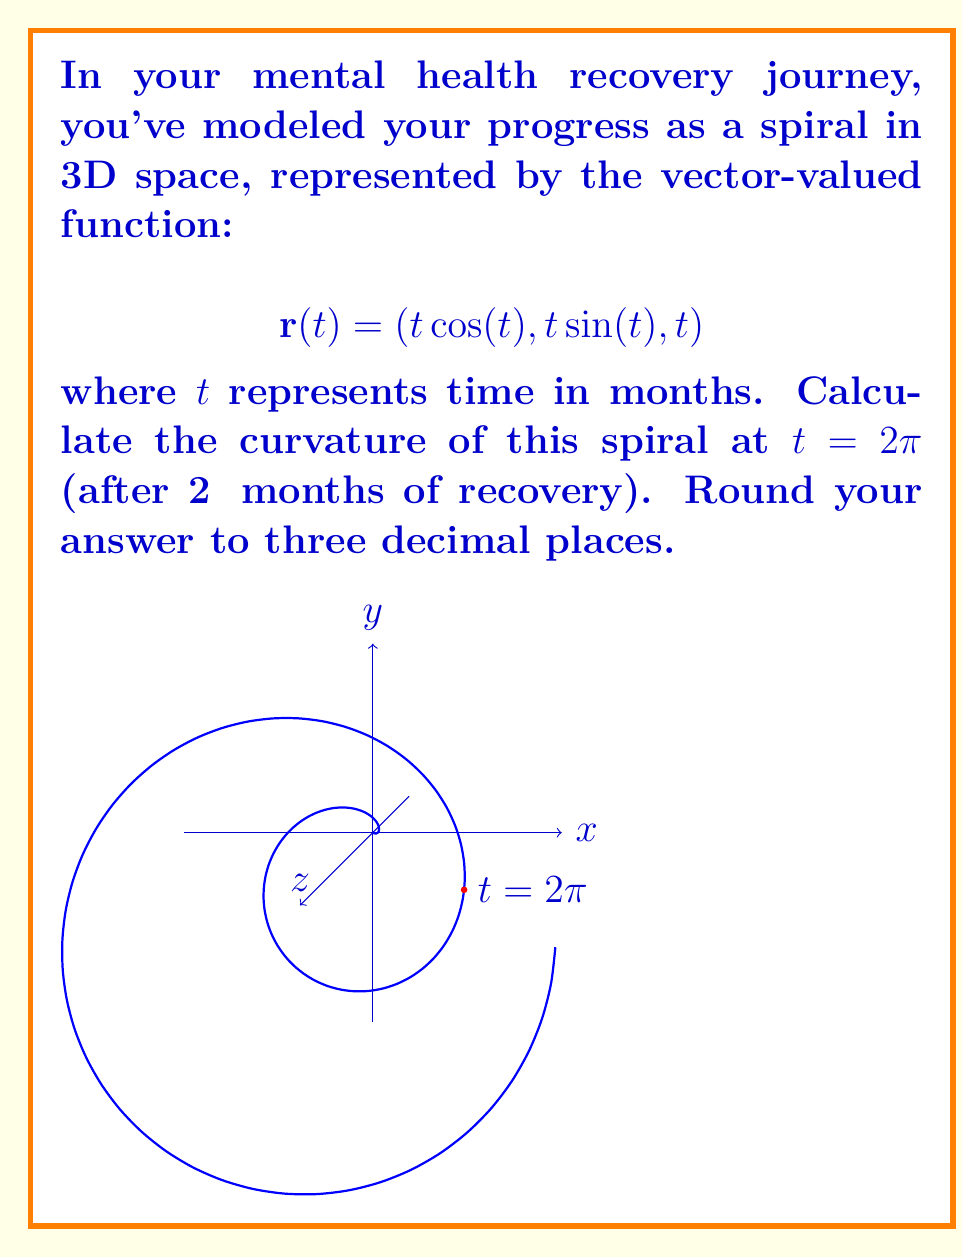Can you answer this question? To calculate the curvature of a vector-valued function, we'll use the formula:

$$\kappa = \frac{|\mathbf{r}'(t) \times \mathbf{r}''(t)|}{|\mathbf{r}'(t)|^3}$$

Step 1: Calculate $\mathbf{r}'(t)$
$$\mathbf{r}'(t) = (\cos(t) - t\sin(t), \sin(t) + t\cos(t), 1)$$

Step 2: Calculate $\mathbf{r}''(t)$
$$\mathbf{r}''(t) = (-2\sin(t) - t\cos(t), 2\cos(t) - t\sin(t), 0)$$

Step 3: Calculate $\mathbf{r}'(t) \times \mathbf{r}''(t)$
$$\mathbf{r}'(t) \times \mathbf{r}''(t) = \begin{vmatrix} 
\mathbf{i} & \mathbf{j} & \mathbf{k} \\
\cos(t) - t\sin(t) & \sin(t) + t\cos(t) & 1 \\
-2\sin(t) - t\cos(t) & 2\cos(t) - t\sin(t) & 0
\end{vmatrix}$$

$$= ((2\cos(t) - t\sin(t)) - (\sin(t) + t\cos(t))(0))\mathbf{i} + ((-2\sin(t) - t\cos(t)) - (\cos(t) - t\sin(t))(0))\mathbf{j} + (\cos(t) - t\sin(t))(2\cos(t) - t\sin(t)) - (\sin(t) + t\cos(t))(-2\sin(t) - t\cos(t))\mathbf{k}$$

Step 4: Calculate $|\mathbf{r}'(t) \times \mathbf{r}''(t)|$ at $t = 2\pi$
At $t = 2\pi$, $\cos(2\pi) = 1$ and $\sin(2\pi) = 0$

$$|\mathbf{r}'(2\pi) \times \mathbf{r}''(2\pi)| = \sqrt{(2)^2 + (-2\pi)^2 + (2 + 2\pi^2)^2} \approx 40.1062$$

Step 5: Calculate $|\mathbf{r}'(t)|$ at $t = 2\pi$
$$|\mathbf{r}'(2\pi)| = \sqrt{(1)^2 + (2\pi)^2 + (1)^2} \approx 6.3830$$

Step 6: Apply the curvature formula
$$\kappa = \frac{40.1062}{6.3830^3} \approx 0.155$$

Therefore, the curvature of the spiral at $t = 2\pi$ is approximately 0.155 (rounded to three decimal places).
Answer: $0.155$ 